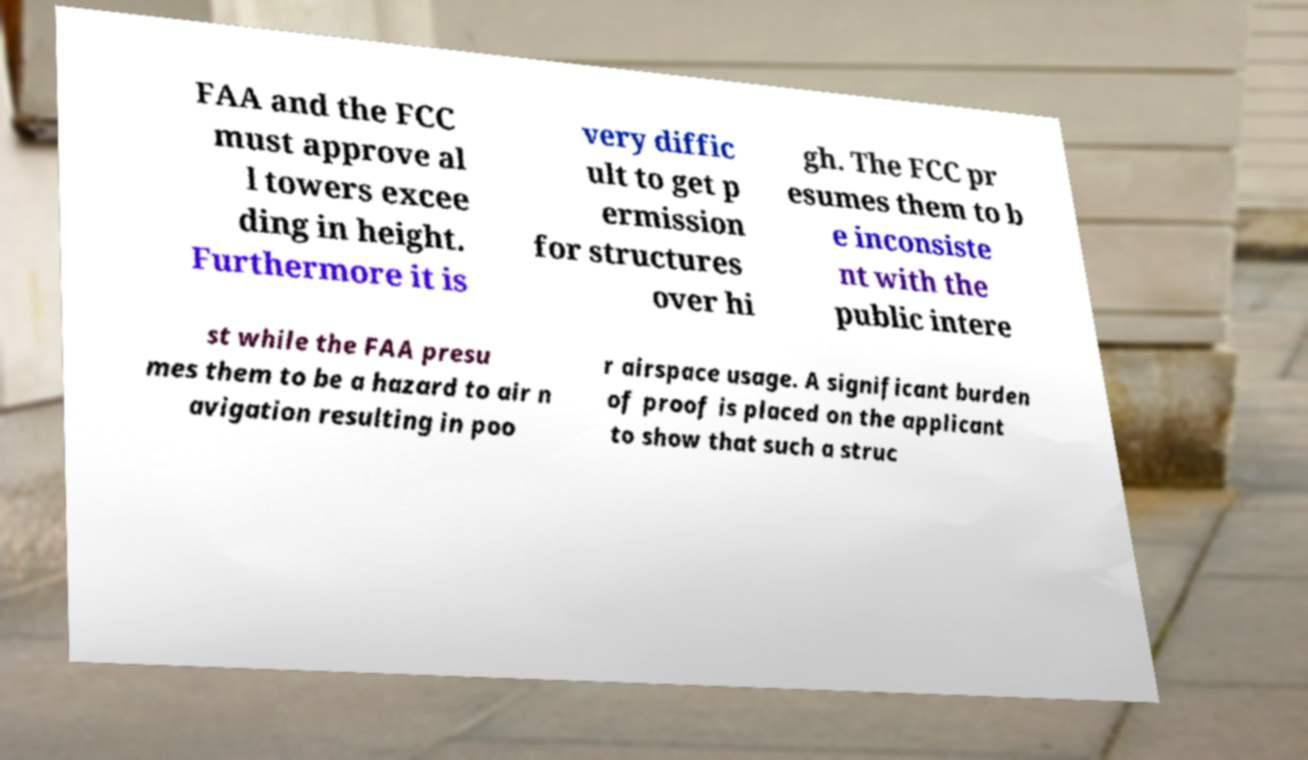Could you extract and type out the text from this image? FAA and the FCC must approve al l towers excee ding in height. Furthermore it is very diffic ult to get p ermission for structures over hi gh. The FCC pr esumes them to b e inconsiste nt with the public intere st while the FAA presu mes them to be a hazard to air n avigation resulting in poo r airspace usage. A significant burden of proof is placed on the applicant to show that such a struc 